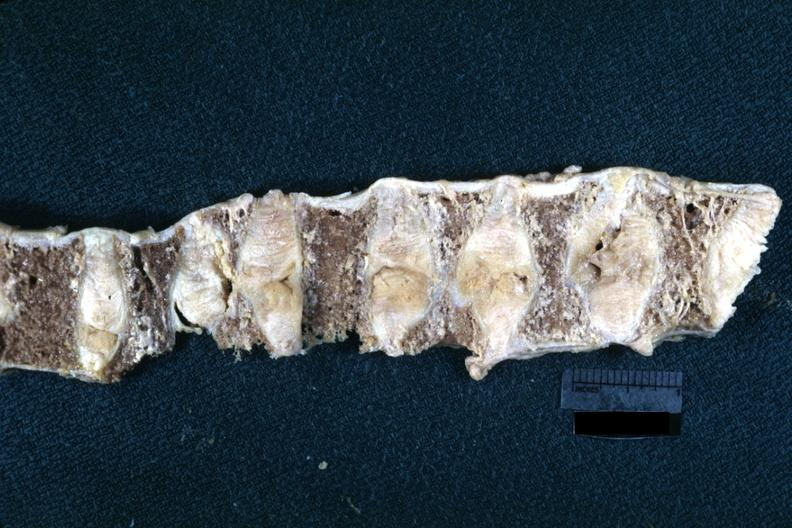why is this lesion probably?
Answer the question using a single word or phrase. Due to osteoporosis 